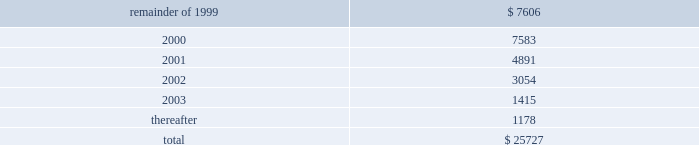The containerboard group ( a division of tenneco packaging inc. ) notes to combined financial statements ( continued ) april 11 , 1999 14 .
Leases ( continued ) to the sale transaction on april 12 , 1999 .
Therefore , the remaining outstanding aggregate minimum rental commitments under noncancelable operating leases are as follows : ( in thousands ) .
15 .
Sale of assets in the second quarter of 1996 , packaging entered into an agreement to form a joint venture with caraustar industries whereby packaging sold its two recycled paperboard mills and a fiber recycling operation and brokerage business to the joint venture in return for cash and a 20% ( 20 % ) equity interest in the joint venture .
Proceeds from the sale were approximately $ 115 million and the group recognized a $ 50 million pretax gain ( $ 30 million after taxes ) in the second quarter of 1996 .
In june , 1998 , packaging sold its remaining 20% ( 20 % ) equity interest in the joint venture to caraustar industries for cash and a note of $ 26000000 .
The group recognized a $ 15 million pretax gain on this transaction .
At april 11 , 1999 , the balance of the note with accrued interest is $ 27122000 .
The note was paid in june , 1999 .
16 .
Subsequent events on august 25 , 1999 , pca and packaging agreed that the acquisition consideration should be reduced as a result of a postclosing price adjustment by an amount equal to $ 20 million plus interest through the date of payment by packaging .
The group recorded $ 11.9 million of this amount as part of the impairment charge on the accompanying financial statements , representing the amount that was previously estimated by packaging .
Pca intends to record the remaining amount in september , 1999 .
In august , 1999 , pca signed purchase and sales agreements with various buyers to sell approximately 405000 acres of timberland .
Pca has completed the sale of approximately 260000 of these acres and expects to complete the sale of the remaining acres by mid-november , 1999. .
What percentage of outstanding aggregate minimum rental commitments under noncancelable operating leases are due in 2001? 
Computations: (4891 / 25727)
Answer: 0.19011. 